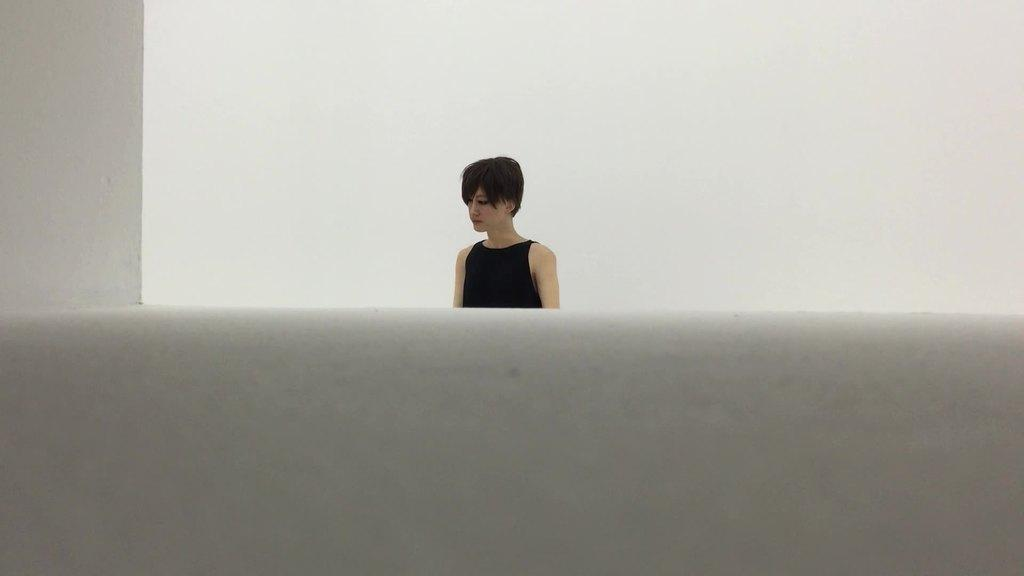Who is present in the image? There is a woman in the image. What is the woman wearing? The woman is wearing a black dress. What type of animal is the woman wishing for in the image? There is no animal or wishing mentioned in the image; it only shows a woman wearing a black dress. 